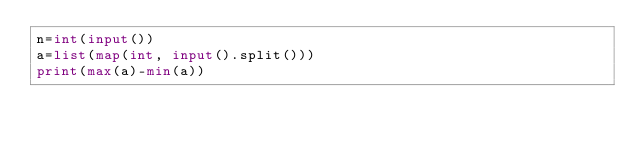<code> <loc_0><loc_0><loc_500><loc_500><_Python_>n=int(input())
a=list(map(int, input().split()))
print(max(a)-min(a))</code> 